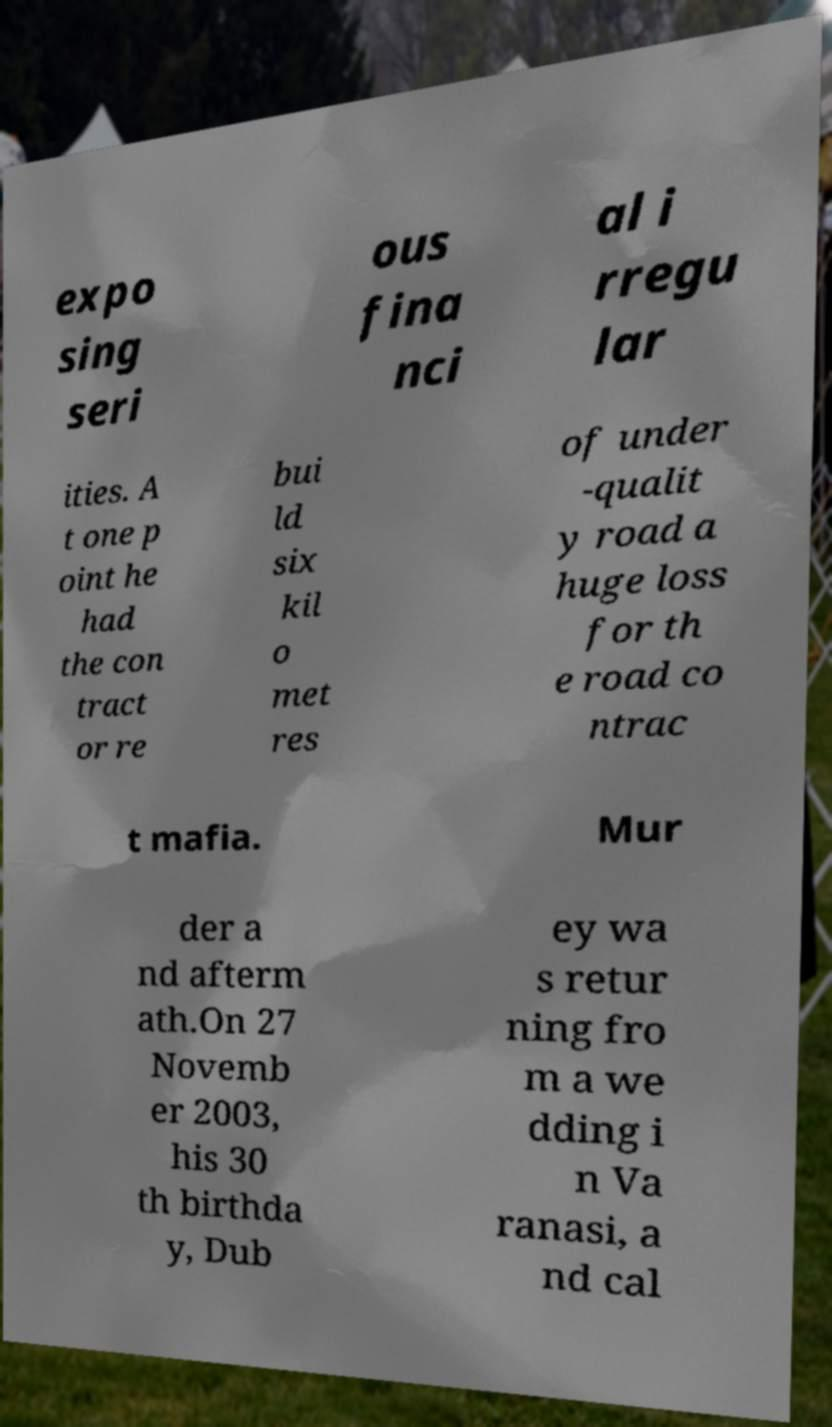Can you accurately transcribe the text from the provided image for me? expo sing seri ous fina nci al i rregu lar ities. A t one p oint he had the con tract or re bui ld six kil o met res of under -qualit y road a huge loss for th e road co ntrac t mafia. Mur der a nd afterm ath.On 27 Novemb er 2003, his 30 th birthda y, Dub ey wa s retur ning fro m a we dding i n Va ranasi, a nd cal 